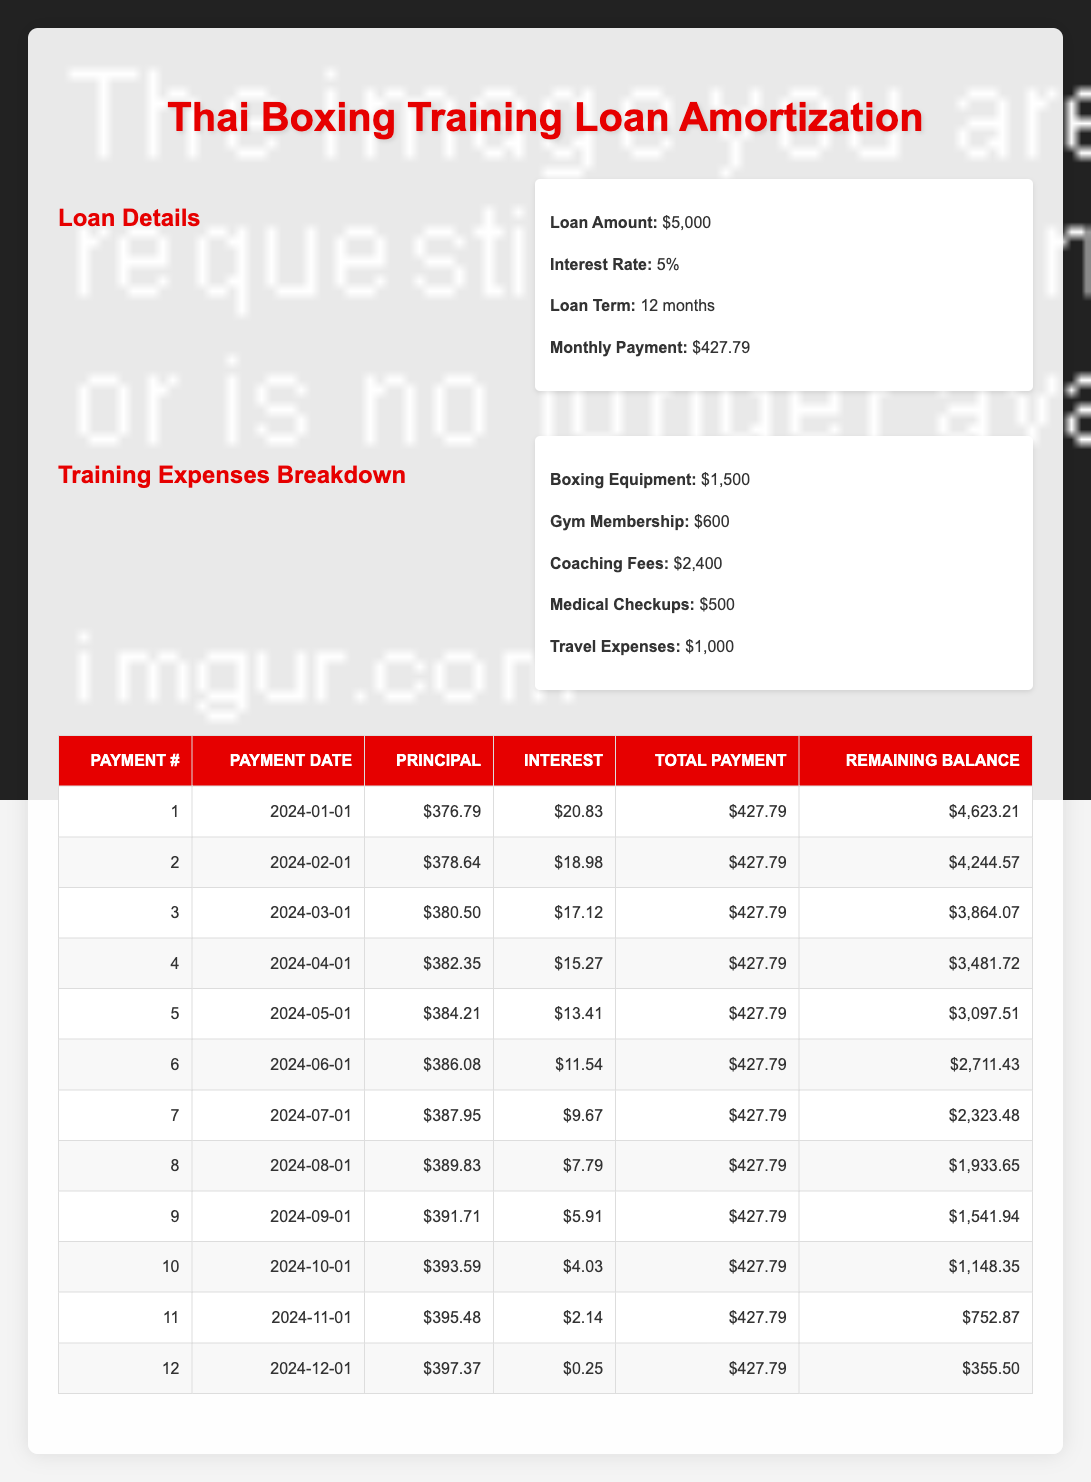What is the total principal payment in the first two months? The principal payments in the first two months are $376.79 and $378.64. Adding these together gives $376.79 + $378.64 = $755.43.
Answer: $755.43 What is the interest payment for the last month? The payment date of the last month is December 1, 2024. The interest payment for that month is shown as $0.25.
Answer: $0.25 Is the monthly payment consistent for all months? The monthly payment of $427.79 is the same for all months, as indicated in each entry under the total payment column.
Answer: Yes What is the remaining balance after the fifth payment? The remaining balance after the fifth payment, which occurs on May 1, 2024, is $3,097.51.
Answer: $3,097.51 How much total interest is paid by the end of the loan term? Summing up the interest payments for all 12 months gives $20.83 + $18.98 + $17.12 + $15.27 + $13.41 + $11.54 + $9.67 + $7.79 + $5.91 + $4.03 + $2.14 + $0.25 = $148.00.
Answer: $148.00 What percentage of the first payment goes towards the principal? The principal payment for the first month is $376.79, and the total payment is $427.79. To find the percentage, calculate (376.79 / 427.79) * 100, which is approximately 88.0%.
Answer: 88.0% How does the amount paid towards the principal change over time? The principal payments are increasing each month, starting from $376.79 in the first month and going up to $397.37 in the last month. This indicates that a larger portion of the payment is applied to the principal as the loan matures.
Answer: Increases monthly What is the total amount paid over the entire loan term? Over 12 months, the total amount paid is calculated as 12 months multiplied by the monthly payment of $427.79, resulting in $427.79 * 12 = $5,133.48.
Answer: $5,133.48 What was the original loan amount compared to the total paid at the end of the term? The original loan amount is $5,000 and the total paid is $5,133.48. The difference of $5,133.48 - $5,000 = $133.48 indicates the extra amount paid over the loan term.
Answer: $5,000 and $5,133.48 At which month is the remaining balance the lowest? The remaining balance after the last payment in December 2024 is $355.50, which is the lowest compared to all previous months.
Answer: Month 12 